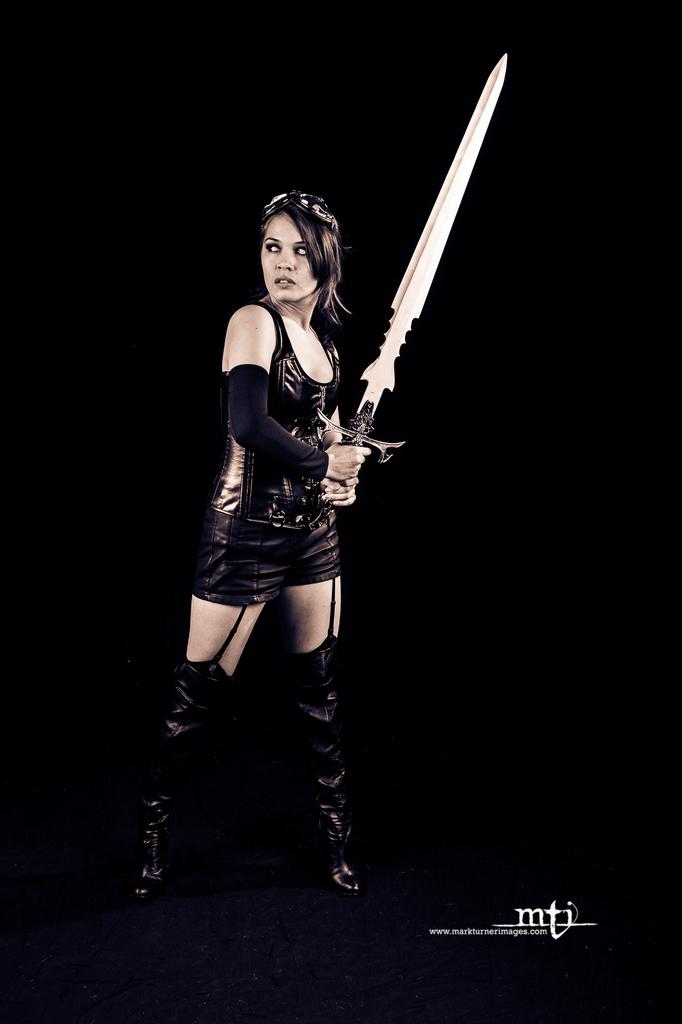What is the main subject of the image? The main subject of the image is a woman. What is the woman holding in the image? The woman is holding a sword. Can you describe the background of the image? The background of the image is dark. Is there any text present in the image? Yes, there is text in the bottom right side of the image. How many tickets can be seen in the woman's hand in the image? There are no tickets visible in the woman's hand in the image. What sign is the woman holding in the image? The woman is not holding a sign in the image; she is holding a sword. 